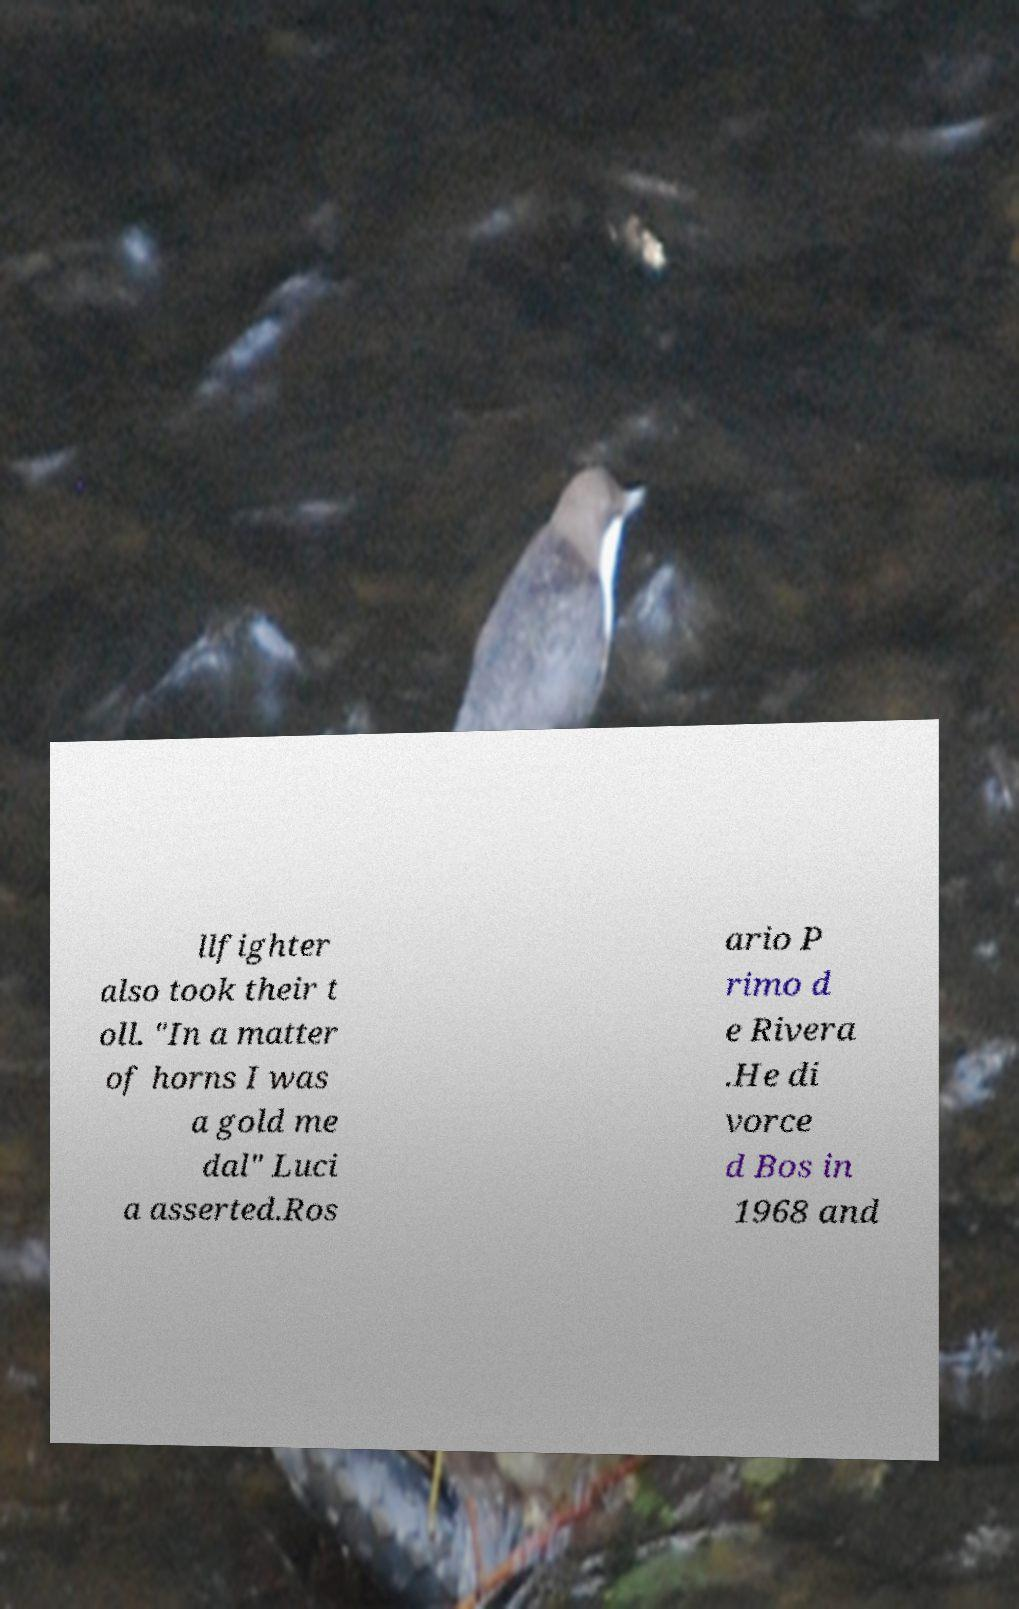Could you assist in decoding the text presented in this image and type it out clearly? llfighter also took their t oll. "In a matter of horns I was a gold me dal" Luci a asserted.Ros ario P rimo d e Rivera .He di vorce d Bos in 1968 and 